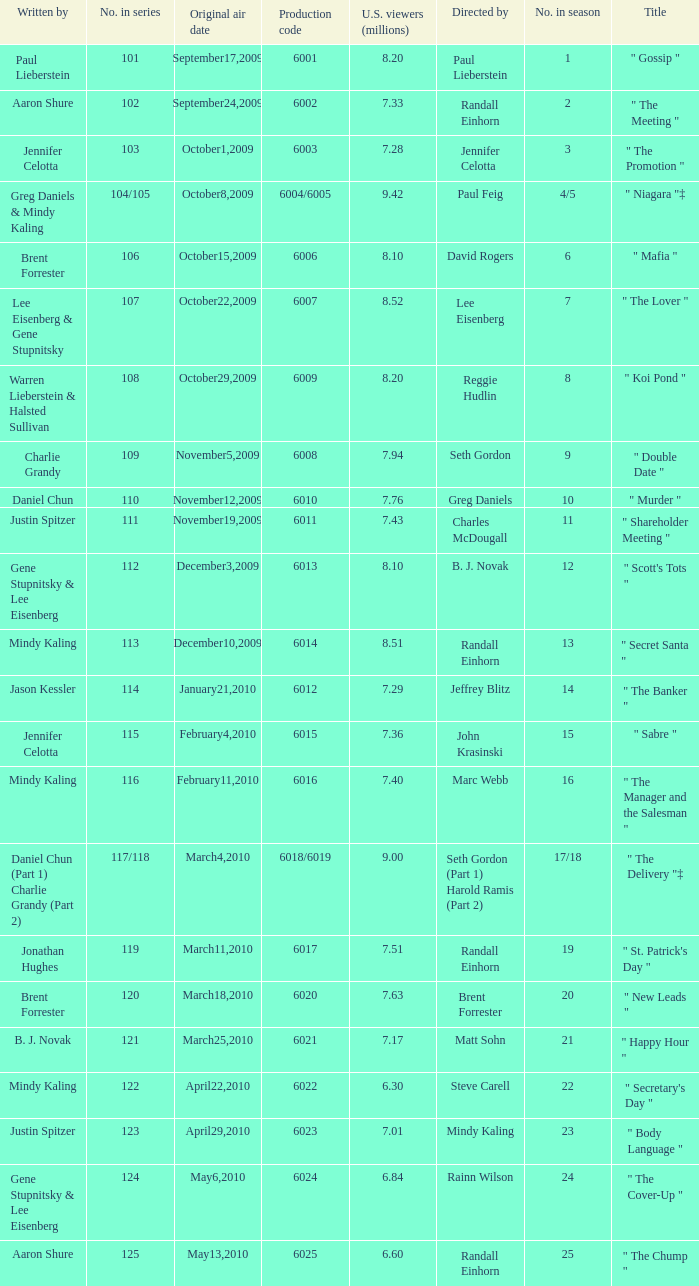Name the production code by paul lieberstein 6001.0. 